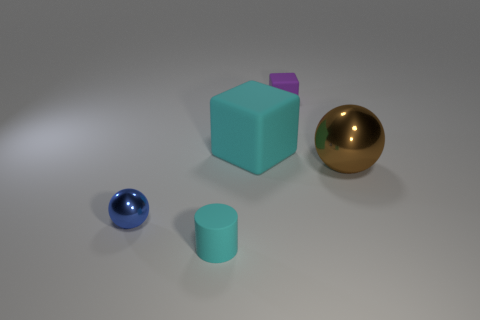Add 1 tiny purple matte cylinders. How many objects exist? 6 Subtract all spheres. How many objects are left? 3 Add 1 purple matte things. How many purple matte things exist? 2 Subtract 0 brown blocks. How many objects are left? 5 Subtract all tiny matte objects. Subtract all brown shiny spheres. How many objects are left? 2 Add 1 cubes. How many cubes are left? 3 